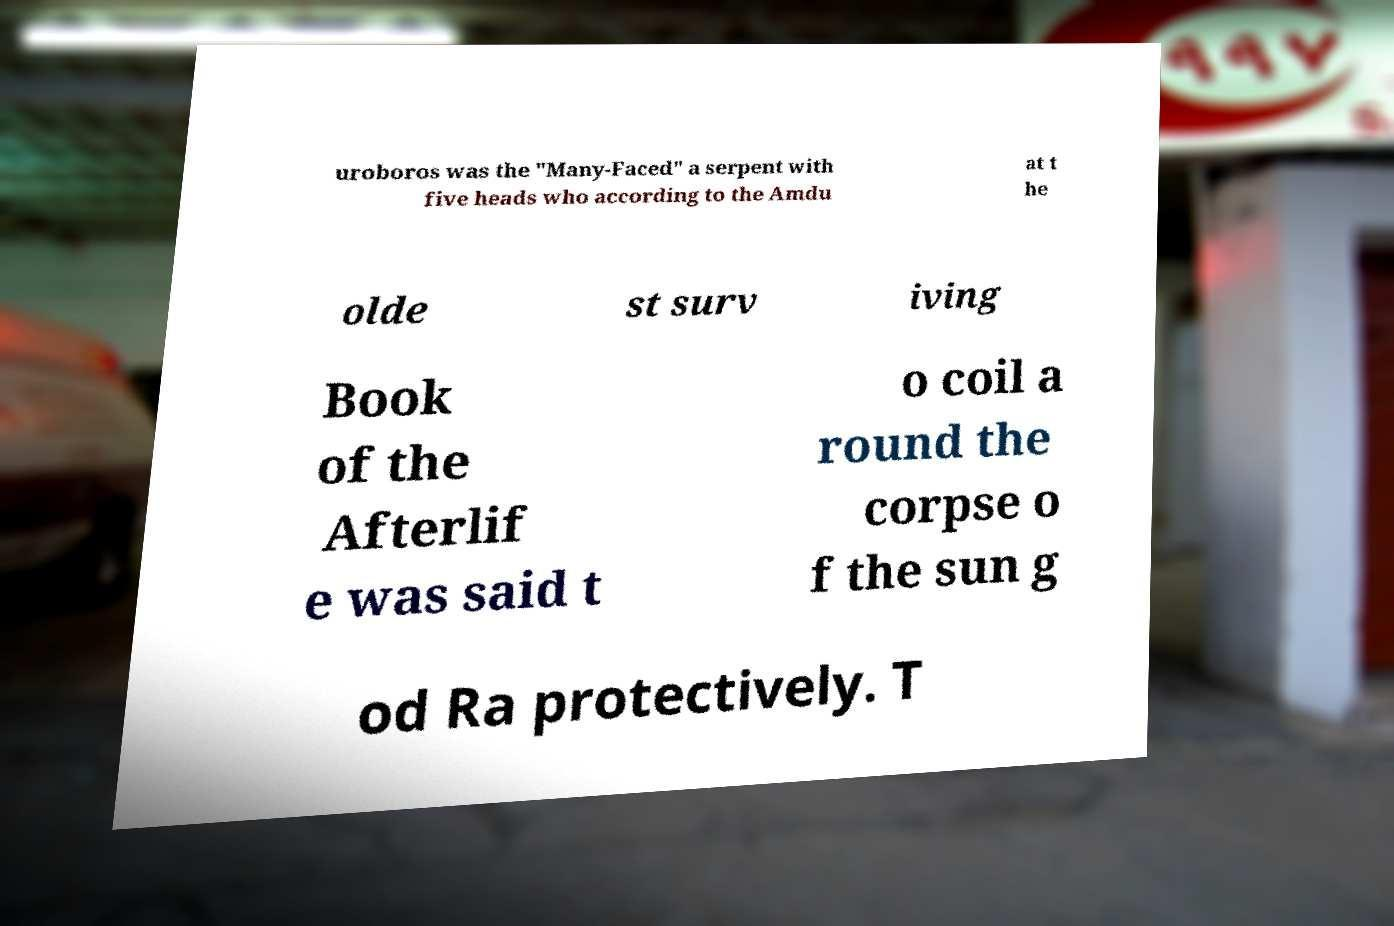What messages or text are displayed in this image? I need them in a readable, typed format. uroboros was the "Many-Faced" a serpent with five heads who according to the Amdu at t he olde st surv iving Book of the Afterlif e was said t o coil a round the corpse o f the sun g od Ra protectively. T 